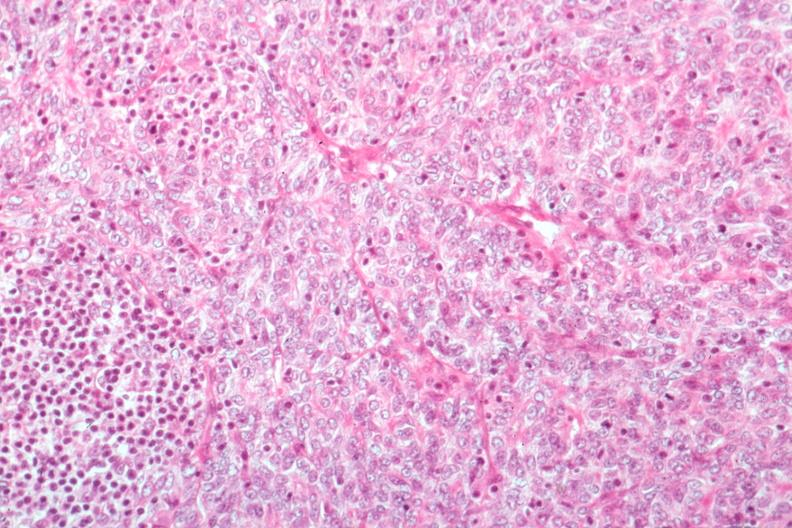s normal ovary present?
Answer the question using a single word or phrase. No 